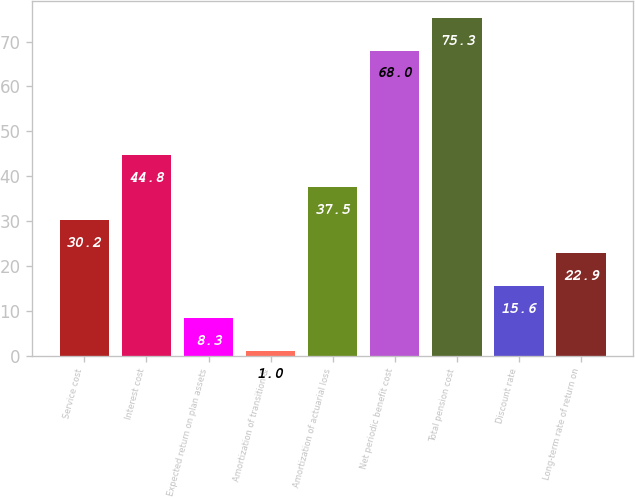Convert chart. <chart><loc_0><loc_0><loc_500><loc_500><bar_chart><fcel>Service cost<fcel>Interest cost<fcel>Expected return on plan assets<fcel>Amortization of transition &<fcel>Amortization of actuarial loss<fcel>Net periodic benefit cost<fcel>Total pension cost<fcel>Discount rate<fcel>Long-term rate of return on<nl><fcel>30.2<fcel>44.8<fcel>8.3<fcel>1<fcel>37.5<fcel>68<fcel>75.3<fcel>15.6<fcel>22.9<nl></chart> 